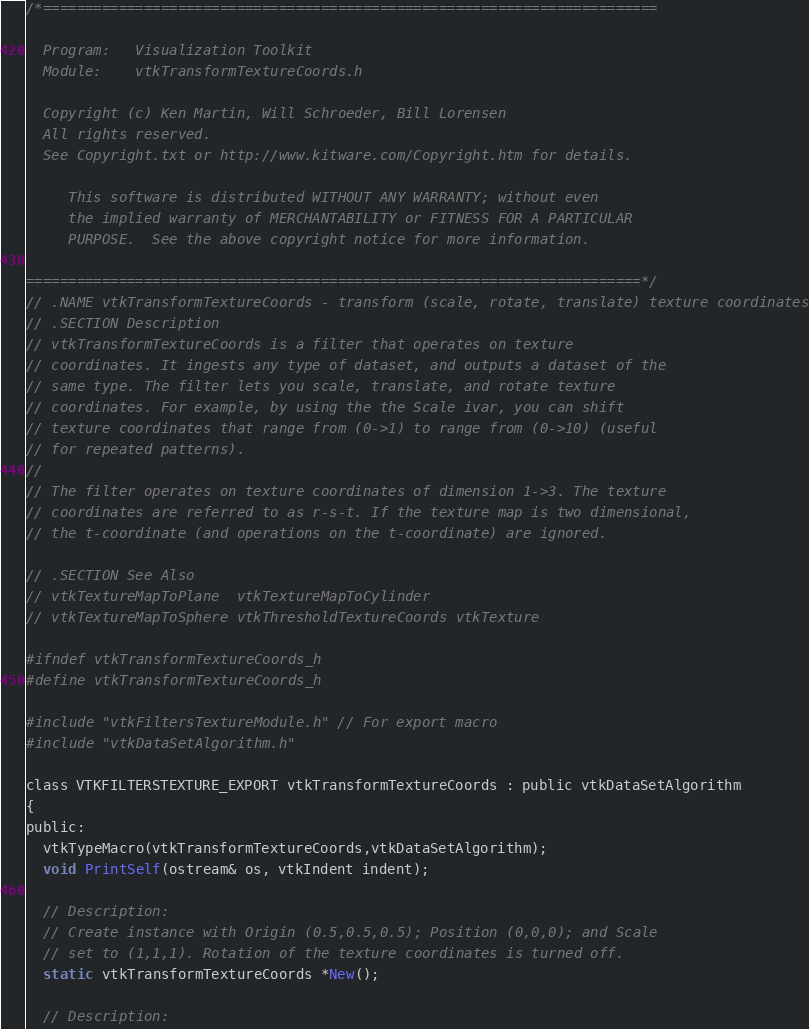Convert code to text. <code><loc_0><loc_0><loc_500><loc_500><_C_>/*=========================================================================

  Program:   Visualization Toolkit
  Module:    vtkTransformTextureCoords.h

  Copyright (c) Ken Martin, Will Schroeder, Bill Lorensen
  All rights reserved.
  See Copyright.txt or http://www.kitware.com/Copyright.htm for details.

     This software is distributed WITHOUT ANY WARRANTY; without even
     the implied warranty of MERCHANTABILITY or FITNESS FOR A PARTICULAR
     PURPOSE.  See the above copyright notice for more information.

=========================================================================*/
// .NAME vtkTransformTextureCoords - transform (scale, rotate, translate) texture coordinates
// .SECTION Description
// vtkTransformTextureCoords is a filter that operates on texture
// coordinates. It ingests any type of dataset, and outputs a dataset of the
// same type. The filter lets you scale, translate, and rotate texture
// coordinates. For example, by using the the Scale ivar, you can shift
// texture coordinates that range from (0->1) to range from (0->10) (useful
// for repeated patterns).
//
// The filter operates on texture coordinates of dimension 1->3. The texture
// coordinates are referred to as r-s-t. If the texture map is two dimensional,
// the t-coordinate (and operations on the t-coordinate) are ignored.

// .SECTION See Also
// vtkTextureMapToPlane  vtkTextureMapToCylinder
// vtkTextureMapToSphere vtkThresholdTextureCoords vtkTexture

#ifndef vtkTransformTextureCoords_h
#define vtkTransformTextureCoords_h

#include "vtkFiltersTextureModule.h" // For export macro
#include "vtkDataSetAlgorithm.h"

class VTKFILTERSTEXTURE_EXPORT vtkTransformTextureCoords : public vtkDataSetAlgorithm
{
public:
  vtkTypeMacro(vtkTransformTextureCoords,vtkDataSetAlgorithm);
  void PrintSelf(ostream& os, vtkIndent indent);

  // Description:
  // Create instance with Origin (0.5,0.5,0.5); Position (0,0,0); and Scale
  // set to (1,1,1). Rotation of the texture coordinates is turned off.
  static vtkTransformTextureCoords *New();

  // Description:</code> 